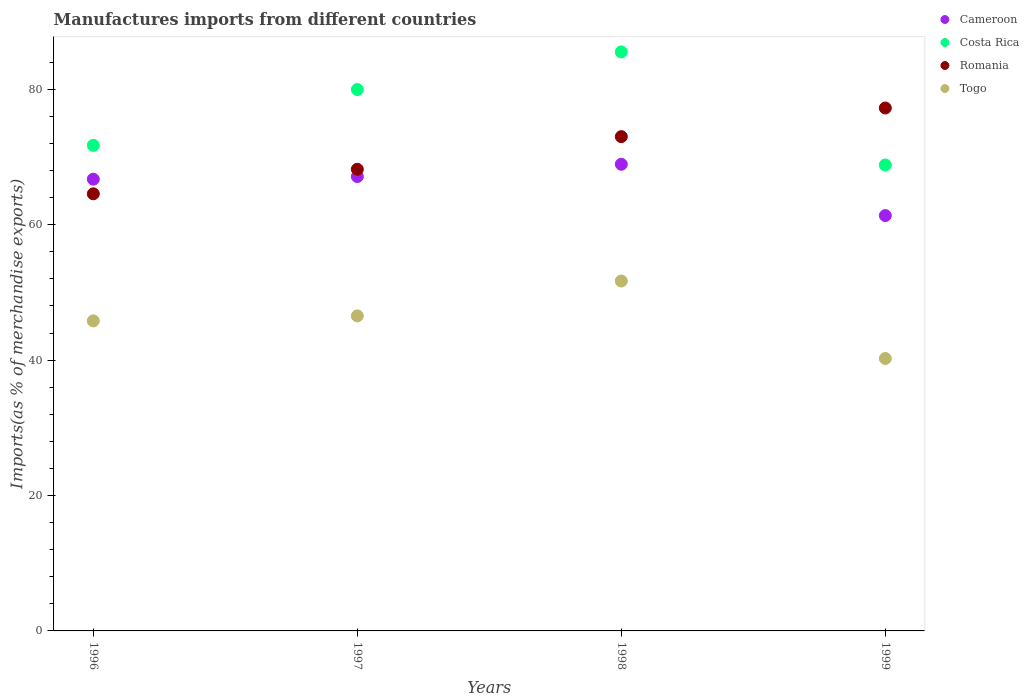What is the percentage of imports to different countries in Costa Rica in 1996?
Ensure brevity in your answer.  71.72. Across all years, what is the maximum percentage of imports to different countries in Togo?
Give a very brief answer. 51.68. Across all years, what is the minimum percentage of imports to different countries in Costa Rica?
Offer a terse response. 68.82. What is the total percentage of imports to different countries in Togo in the graph?
Give a very brief answer. 184.25. What is the difference between the percentage of imports to different countries in Romania in 1996 and that in 1998?
Your answer should be very brief. -8.44. What is the difference between the percentage of imports to different countries in Togo in 1999 and the percentage of imports to different countries in Cameroon in 1996?
Ensure brevity in your answer.  -26.49. What is the average percentage of imports to different countries in Romania per year?
Ensure brevity in your answer.  70.75. In the year 1997, what is the difference between the percentage of imports to different countries in Romania and percentage of imports to different countries in Costa Rica?
Your answer should be compact. -11.78. In how many years, is the percentage of imports to different countries in Costa Rica greater than 8 %?
Give a very brief answer. 4. What is the ratio of the percentage of imports to different countries in Cameroon in 1996 to that in 1998?
Offer a terse response. 0.97. What is the difference between the highest and the second highest percentage of imports to different countries in Costa Rica?
Offer a very short reply. 5.56. What is the difference between the highest and the lowest percentage of imports to different countries in Romania?
Your response must be concise. 12.67. In how many years, is the percentage of imports to different countries in Togo greater than the average percentage of imports to different countries in Togo taken over all years?
Provide a short and direct response. 2. Is it the case that in every year, the sum of the percentage of imports to different countries in Romania and percentage of imports to different countries in Cameroon  is greater than the sum of percentage of imports to different countries in Costa Rica and percentage of imports to different countries in Togo?
Make the answer very short. No. Is the percentage of imports to different countries in Togo strictly greater than the percentage of imports to different countries in Cameroon over the years?
Ensure brevity in your answer.  No. Is the percentage of imports to different countries in Cameroon strictly less than the percentage of imports to different countries in Romania over the years?
Provide a short and direct response. No. How many years are there in the graph?
Offer a very short reply. 4. Does the graph contain any zero values?
Provide a short and direct response. No. Does the graph contain grids?
Provide a short and direct response. No. Where does the legend appear in the graph?
Offer a very short reply. Top right. What is the title of the graph?
Offer a very short reply. Manufactures imports from different countries. What is the label or title of the Y-axis?
Provide a short and direct response. Imports(as % of merchandise exports). What is the Imports(as % of merchandise exports) in Cameroon in 1996?
Give a very brief answer. 66.72. What is the Imports(as % of merchandise exports) in Costa Rica in 1996?
Offer a very short reply. 71.72. What is the Imports(as % of merchandise exports) in Romania in 1996?
Ensure brevity in your answer.  64.56. What is the Imports(as % of merchandise exports) of Togo in 1996?
Provide a succinct answer. 45.8. What is the Imports(as % of merchandise exports) in Cameroon in 1997?
Make the answer very short. 67.11. What is the Imports(as % of merchandise exports) of Costa Rica in 1997?
Offer a terse response. 79.97. What is the Imports(as % of merchandise exports) of Romania in 1997?
Ensure brevity in your answer.  68.19. What is the Imports(as % of merchandise exports) of Togo in 1997?
Provide a short and direct response. 46.53. What is the Imports(as % of merchandise exports) of Cameroon in 1998?
Your answer should be compact. 68.93. What is the Imports(as % of merchandise exports) in Costa Rica in 1998?
Provide a short and direct response. 85.52. What is the Imports(as % of merchandise exports) in Romania in 1998?
Offer a terse response. 73.01. What is the Imports(as % of merchandise exports) of Togo in 1998?
Ensure brevity in your answer.  51.68. What is the Imports(as % of merchandise exports) in Cameroon in 1999?
Ensure brevity in your answer.  61.35. What is the Imports(as % of merchandise exports) of Costa Rica in 1999?
Your answer should be compact. 68.82. What is the Imports(as % of merchandise exports) in Romania in 1999?
Keep it short and to the point. 77.24. What is the Imports(as % of merchandise exports) in Togo in 1999?
Your answer should be compact. 40.24. Across all years, what is the maximum Imports(as % of merchandise exports) of Cameroon?
Provide a succinct answer. 68.93. Across all years, what is the maximum Imports(as % of merchandise exports) in Costa Rica?
Offer a very short reply. 85.52. Across all years, what is the maximum Imports(as % of merchandise exports) in Romania?
Your response must be concise. 77.24. Across all years, what is the maximum Imports(as % of merchandise exports) in Togo?
Make the answer very short. 51.68. Across all years, what is the minimum Imports(as % of merchandise exports) of Cameroon?
Make the answer very short. 61.35. Across all years, what is the minimum Imports(as % of merchandise exports) in Costa Rica?
Ensure brevity in your answer.  68.82. Across all years, what is the minimum Imports(as % of merchandise exports) in Romania?
Make the answer very short. 64.56. Across all years, what is the minimum Imports(as % of merchandise exports) in Togo?
Offer a very short reply. 40.24. What is the total Imports(as % of merchandise exports) of Cameroon in the graph?
Ensure brevity in your answer.  264.12. What is the total Imports(as % of merchandise exports) in Costa Rica in the graph?
Give a very brief answer. 306.03. What is the total Imports(as % of merchandise exports) in Romania in the graph?
Keep it short and to the point. 283. What is the total Imports(as % of merchandise exports) in Togo in the graph?
Offer a terse response. 184.25. What is the difference between the Imports(as % of merchandise exports) in Cameroon in 1996 and that in 1997?
Your answer should be compact. -0.39. What is the difference between the Imports(as % of merchandise exports) in Costa Rica in 1996 and that in 1997?
Keep it short and to the point. -8.25. What is the difference between the Imports(as % of merchandise exports) in Romania in 1996 and that in 1997?
Your answer should be compact. -3.62. What is the difference between the Imports(as % of merchandise exports) in Togo in 1996 and that in 1997?
Ensure brevity in your answer.  -0.73. What is the difference between the Imports(as % of merchandise exports) of Cameroon in 1996 and that in 1998?
Ensure brevity in your answer.  -2.2. What is the difference between the Imports(as % of merchandise exports) in Costa Rica in 1996 and that in 1998?
Provide a succinct answer. -13.81. What is the difference between the Imports(as % of merchandise exports) in Romania in 1996 and that in 1998?
Your answer should be very brief. -8.44. What is the difference between the Imports(as % of merchandise exports) of Togo in 1996 and that in 1998?
Your answer should be very brief. -5.89. What is the difference between the Imports(as % of merchandise exports) of Cameroon in 1996 and that in 1999?
Keep it short and to the point. 5.37. What is the difference between the Imports(as % of merchandise exports) of Costa Rica in 1996 and that in 1999?
Make the answer very short. 2.89. What is the difference between the Imports(as % of merchandise exports) of Romania in 1996 and that in 1999?
Your answer should be compact. -12.67. What is the difference between the Imports(as % of merchandise exports) of Togo in 1996 and that in 1999?
Your answer should be compact. 5.56. What is the difference between the Imports(as % of merchandise exports) in Cameroon in 1997 and that in 1998?
Your answer should be very brief. -1.81. What is the difference between the Imports(as % of merchandise exports) of Costa Rica in 1997 and that in 1998?
Offer a very short reply. -5.56. What is the difference between the Imports(as % of merchandise exports) in Romania in 1997 and that in 1998?
Keep it short and to the point. -4.82. What is the difference between the Imports(as % of merchandise exports) in Togo in 1997 and that in 1998?
Provide a short and direct response. -5.15. What is the difference between the Imports(as % of merchandise exports) in Cameroon in 1997 and that in 1999?
Provide a short and direct response. 5.76. What is the difference between the Imports(as % of merchandise exports) in Costa Rica in 1997 and that in 1999?
Ensure brevity in your answer.  11.14. What is the difference between the Imports(as % of merchandise exports) of Romania in 1997 and that in 1999?
Your answer should be very brief. -9.05. What is the difference between the Imports(as % of merchandise exports) of Togo in 1997 and that in 1999?
Offer a very short reply. 6.29. What is the difference between the Imports(as % of merchandise exports) in Cameroon in 1998 and that in 1999?
Your response must be concise. 7.58. What is the difference between the Imports(as % of merchandise exports) in Costa Rica in 1998 and that in 1999?
Ensure brevity in your answer.  16.7. What is the difference between the Imports(as % of merchandise exports) in Romania in 1998 and that in 1999?
Provide a succinct answer. -4.23. What is the difference between the Imports(as % of merchandise exports) in Togo in 1998 and that in 1999?
Keep it short and to the point. 11.45. What is the difference between the Imports(as % of merchandise exports) of Cameroon in 1996 and the Imports(as % of merchandise exports) of Costa Rica in 1997?
Your answer should be compact. -13.24. What is the difference between the Imports(as % of merchandise exports) in Cameroon in 1996 and the Imports(as % of merchandise exports) in Romania in 1997?
Your answer should be compact. -1.46. What is the difference between the Imports(as % of merchandise exports) of Cameroon in 1996 and the Imports(as % of merchandise exports) of Togo in 1997?
Ensure brevity in your answer.  20.19. What is the difference between the Imports(as % of merchandise exports) in Costa Rica in 1996 and the Imports(as % of merchandise exports) in Romania in 1997?
Make the answer very short. 3.53. What is the difference between the Imports(as % of merchandise exports) of Costa Rica in 1996 and the Imports(as % of merchandise exports) of Togo in 1997?
Provide a succinct answer. 25.19. What is the difference between the Imports(as % of merchandise exports) in Romania in 1996 and the Imports(as % of merchandise exports) in Togo in 1997?
Your answer should be compact. 18.03. What is the difference between the Imports(as % of merchandise exports) in Cameroon in 1996 and the Imports(as % of merchandise exports) in Costa Rica in 1998?
Your response must be concise. -18.8. What is the difference between the Imports(as % of merchandise exports) in Cameroon in 1996 and the Imports(as % of merchandise exports) in Romania in 1998?
Make the answer very short. -6.28. What is the difference between the Imports(as % of merchandise exports) in Cameroon in 1996 and the Imports(as % of merchandise exports) in Togo in 1998?
Your answer should be compact. 15.04. What is the difference between the Imports(as % of merchandise exports) of Costa Rica in 1996 and the Imports(as % of merchandise exports) of Romania in 1998?
Ensure brevity in your answer.  -1.29. What is the difference between the Imports(as % of merchandise exports) of Costa Rica in 1996 and the Imports(as % of merchandise exports) of Togo in 1998?
Your answer should be compact. 20.03. What is the difference between the Imports(as % of merchandise exports) in Romania in 1996 and the Imports(as % of merchandise exports) in Togo in 1998?
Your response must be concise. 12.88. What is the difference between the Imports(as % of merchandise exports) in Cameroon in 1996 and the Imports(as % of merchandise exports) in Romania in 1999?
Keep it short and to the point. -10.51. What is the difference between the Imports(as % of merchandise exports) of Cameroon in 1996 and the Imports(as % of merchandise exports) of Togo in 1999?
Your response must be concise. 26.49. What is the difference between the Imports(as % of merchandise exports) in Costa Rica in 1996 and the Imports(as % of merchandise exports) in Romania in 1999?
Ensure brevity in your answer.  -5.52. What is the difference between the Imports(as % of merchandise exports) of Costa Rica in 1996 and the Imports(as % of merchandise exports) of Togo in 1999?
Give a very brief answer. 31.48. What is the difference between the Imports(as % of merchandise exports) in Romania in 1996 and the Imports(as % of merchandise exports) in Togo in 1999?
Keep it short and to the point. 24.33. What is the difference between the Imports(as % of merchandise exports) in Cameroon in 1997 and the Imports(as % of merchandise exports) in Costa Rica in 1998?
Your answer should be compact. -18.41. What is the difference between the Imports(as % of merchandise exports) in Cameroon in 1997 and the Imports(as % of merchandise exports) in Romania in 1998?
Offer a very short reply. -5.9. What is the difference between the Imports(as % of merchandise exports) of Cameroon in 1997 and the Imports(as % of merchandise exports) of Togo in 1998?
Your response must be concise. 15.43. What is the difference between the Imports(as % of merchandise exports) in Costa Rica in 1997 and the Imports(as % of merchandise exports) in Romania in 1998?
Provide a short and direct response. 6.96. What is the difference between the Imports(as % of merchandise exports) of Costa Rica in 1997 and the Imports(as % of merchandise exports) of Togo in 1998?
Make the answer very short. 28.28. What is the difference between the Imports(as % of merchandise exports) of Romania in 1997 and the Imports(as % of merchandise exports) of Togo in 1998?
Ensure brevity in your answer.  16.5. What is the difference between the Imports(as % of merchandise exports) of Cameroon in 1997 and the Imports(as % of merchandise exports) of Costa Rica in 1999?
Offer a terse response. -1.71. What is the difference between the Imports(as % of merchandise exports) of Cameroon in 1997 and the Imports(as % of merchandise exports) of Romania in 1999?
Your answer should be very brief. -10.13. What is the difference between the Imports(as % of merchandise exports) of Cameroon in 1997 and the Imports(as % of merchandise exports) of Togo in 1999?
Provide a succinct answer. 26.88. What is the difference between the Imports(as % of merchandise exports) in Costa Rica in 1997 and the Imports(as % of merchandise exports) in Romania in 1999?
Provide a short and direct response. 2.73. What is the difference between the Imports(as % of merchandise exports) in Costa Rica in 1997 and the Imports(as % of merchandise exports) in Togo in 1999?
Offer a terse response. 39.73. What is the difference between the Imports(as % of merchandise exports) of Romania in 1997 and the Imports(as % of merchandise exports) of Togo in 1999?
Your answer should be very brief. 27.95. What is the difference between the Imports(as % of merchandise exports) of Cameroon in 1998 and the Imports(as % of merchandise exports) of Costa Rica in 1999?
Your response must be concise. 0.1. What is the difference between the Imports(as % of merchandise exports) of Cameroon in 1998 and the Imports(as % of merchandise exports) of Romania in 1999?
Ensure brevity in your answer.  -8.31. What is the difference between the Imports(as % of merchandise exports) of Cameroon in 1998 and the Imports(as % of merchandise exports) of Togo in 1999?
Make the answer very short. 28.69. What is the difference between the Imports(as % of merchandise exports) of Costa Rica in 1998 and the Imports(as % of merchandise exports) of Romania in 1999?
Keep it short and to the point. 8.29. What is the difference between the Imports(as % of merchandise exports) in Costa Rica in 1998 and the Imports(as % of merchandise exports) in Togo in 1999?
Ensure brevity in your answer.  45.29. What is the difference between the Imports(as % of merchandise exports) in Romania in 1998 and the Imports(as % of merchandise exports) in Togo in 1999?
Ensure brevity in your answer.  32.77. What is the average Imports(as % of merchandise exports) of Cameroon per year?
Make the answer very short. 66.03. What is the average Imports(as % of merchandise exports) in Costa Rica per year?
Ensure brevity in your answer.  76.51. What is the average Imports(as % of merchandise exports) in Romania per year?
Your response must be concise. 70.75. What is the average Imports(as % of merchandise exports) in Togo per year?
Your answer should be compact. 46.06. In the year 1996, what is the difference between the Imports(as % of merchandise exports) of Cameroon and Imports(as % of merchandise exports) of Costa Rica?
Your answer should be compact. -4.99. In the year 1996, what is the difference between the Imports(as % of merchandise exports) of Cameroon and Imports(as % of merchandise exports) of Romania?
Offer a very short reply. 2.16. In the year 1996, what is the difference between the Imports(as % of merchandise exports) of Cameroon and Imports(as % of merchandise exports) of Togo?
Give a very brief answer. 20.93. In the year 1996, what is the difference between the Imports(as % of merchandise exports) in Costa Rica and Imports(as % of merchandise exports) in Romania?
Make the answer very short. 7.15. In the year 1996, what is the difference between the Imports(as % of merchandise exports) in Costa Rica and Imports(as % of merchandise exports) in Togo?
Offer a terse response. 25.92. In the year 1996, what is the difference between the Imports(as % of merchandise exports) of Romania and Imports(as % of merchandise exports) of Togo?
Offer a terse response. 18.77. In the year 1997, what is the difference between the Imports(as % of merchandise exports) of Cameroon and Imports(as % of merchandise exports) of Costa Rica?
Your answer should be compact. -12.85. In the year 1997, what is the difference between the Imports(as % of merchandise exports) of Cameroon and Imports(as % of merchandise exports) of Romania?
Offer a terse response. -1.08. In the year 1997, what is the difference between the Imports(as % of merchandise exports) in Cameroon and Imports(as % of merchandise exports) in Togo?
Make the answer very short. 20.58. In the year 1997, what is the difference between the Imports(as % of merchandise exports) of Costa Rica and Imports(as % of merchandise exports) of Romania?
Keep it short and to the point. 11.78. In the year 1997, what is the difference between the Imports(as % of merchandise exports) in Costa Rica and Imports(as % of merchandise exports) in Togo?
Provide a succinct answer. 33.43. In the year 1997, what is the difference between the Imports(as % of merchandise exports) in Romania and Imports(as % of merchandise exports) in Togo?
Offer a terse response. 21.66. In the year 1998, what is the difference between the Imports(as % of merchandise exports) of Cameroon and Imports(as % of merchandise exports) of Costa Rica?
Ensure brevity in your answer.  -16.6. In the year 1998, what is the difference between the Imports(as % of merchandise exports) of Cameroon and Imports(as % of merchandise exports) of Romania?
Provide a succinct answer. -4.08. In the year 1998, what is the difference between the Imports(as % of merchandise exports) in Cameroon and Imports(as % of merchandise exports) in Togo?
Ensure brevity in your answer.  17.24. In the year 1998, what is the difference between the Imports(as % of merchandise exports) of Costa Rica and Imports(as % of merchandise exports) of Romania?
Your answer should be compact. 12.51. In the year 1998, what is the difference between the Imports(as % of merchandise exports) of Costa Rica and Imports(as % of merchandise exports) of Togo?
Keep it short and to the point. 33.84. In the year 1998, what is the difference between the Imports(as % of merchandise exports) in Romania and Imports(as % of merchandise exports) in Togo?
Your answer should be very brief. 21.33. In the year 1999, what is the difference between the Imports(as % of merchandise exports) in Cameroon and Imports(as % of merchandise exports) in Costa Rica?
Your answer should be very brief. -7.47. In the year 1999, what is the difference between the Imports(as % of merchandise exports) of Cameroon and Imports(as % of merchandise exports) of Romania?
Give a very brief answer. -15.89. In the year 1999, what is the difference between the Imports(as % of merchandise exports) of Cameroon and Imports(as % of merchandise exports) of Togo?
Provide a short and direct response. 21.11. In the year 1999, what is the difference between the Imports(as % of merchandise exports) of Costa Rica and Imports(as % of merchandise exports) of Romania?
Keep it short and to the point. -8.41. In the year 1999, what is the difference between the Imports(as % of merchandise exports) of Costa Rica and Imports(as % of merchandise exports) of Togo?
Provide a succinct answer. 28.59. In the year 1999, what is the difference between the Imports(as % of merchandise exports) in Romania and Imports(as % of merchandise exports) in Togo?
Make the answer very short. 37. What is the ratio of the Imports(as % of merchandise exports) of Costa Rica in 1996 to that in 1997?
Make the answer very short. 0.9. What is the ratio of the Imports(as % of merchandise exports) of Romania in 1996 to that in 1997?
Ensure brevity in your answer.  0.95. What is the ratio of the Imports(as % of merchandise exports) of Togo in 1996 to that in 1997?
Give a very brief answer. 0.98. What is the ratio of the Imports(as % of merchandise exports) in Cameroon in 1996 to that in 1998?
Offer a very short reply. 0.97. What is the ratio of the Imports(as % of merchandise exports) of Costa Rica in 1996 to that in 1998?
Your response must be concise. 0.84. What is the ratio of the Imports(as % of merchandise exports) of Romania in 1996 to that in 1998?
Offer a terse response. 0.88. What is the ratio of the Imports(as % of merchandise exports) of Togo in 1996 to that in 1998?
Your answer should be very brief. 0.89. What is the ratio of the Imports(as % of merchandise exports) in Cameroon in 1996 to that in 1999?
Provide a short and direct response. 1.09. What is the ratio of the Imports(as % of merchandise exports) of Costa Rica in 1996 to that in 1999?
Your answer should be very brief. 1.04. What is the ratio of the Imports(as % of merchandise exports) in Romania in 1996 to that in 1999?
Your answer should be compact. 0.84. What is the ratio of the Imports(as % of merchandise exports) of Togo in 1996 to that in 1999?
Make the answer very short. 1.14. What is the ratio of the Imports(as % of merchandise exports) of Cameroon in 1997 to that in 1998?
Your answer should be compact. 0.97. What is the ratio of the Imports(as % of merchandise exports) in Costa Rica in 1997 to that in 1998?
Give a very brief answer. 0.94. What is the ratio of the Imports(as % of merchandise exports) of Romania in 1997 to that in 1998?
Give a very brief answer. 0.93. What is the ratio of the Imports(as % of merchandise exports) in Togo in 1997 to that in 1998?
Your answer should be compact. 0.9. What is the ratio of the Imports(as % of merchandise exports) of Cameroon in 1997 to that in 1999?
Your answer should be very brief. 1.09. What is the ratio of the Imports(as % of merchandise exports) in Costa Rica in 1997 to that in 1999?
Offer a very short reply. 1.16. What is the ratio of the Imports(as % of merchandise exports) in Romania in 1997 to that in 1999?
Provide a succinct answer. 0.88. What is the ratio of the Imports(as % of merchandise exports) of Togo in 1997 to that in 1999?
Provide a succinct answer. 1.16. What is the ratio of the Imports(as % of merchandise exports) of Cameroon in 1998 to that in 1999?
Ensure brevity in your answer.  1.12. What is the ratio of the Imports(as % of merchandise exports) in Costa Rica in 1998 to that in 1999?
Make the answer very short. 1.24. What is the ratio of the Imports(as % of merchandise exports) of Romania in 1998 to that in 1999?
Ensure brevity in your answer.  0.95. What is the ratio of the Imports(as % of merchandise exports) of Togo in 1998 to that in 1999?
Ensure brevity in your answer.  1.28. What is the difference between the highest and the second highest Imports(as % of merchandise exports) in Cameroon?
Keep it short and to the point. 1.81. What is the difference between the highest and the second highest Imports(as % of merchandise exports) of Costa Rica?
Your answer should be very brief. 5.56. What is the difference between the highest and the second highest Imports(as % of merchandise exports) in Romania?
Your response must be concise. 4.23. What is the difference between the highest and the second highest Imports(as % of merchandise exports) of Togo?
Your answer should be compact. 5.15. What is the difference between the highest and the lowest Imports(as % of merchandise exports) in Cameroon?
Offer a very short reply. 7.58. What is the difference between the highest and the lowest Imports(as % of merchandise exports) in Costa Rica?
Provide a short and direct response. 16.7. What is the difference between the highest and the lowest Imports(as % of merchandise exports) of Romania?
Your answer should be compact. 12.67. What is the difference between the highest and the lowest Imports(as % of merchandise exports) in Togo?
Provide a succinct answer. 11.45. 